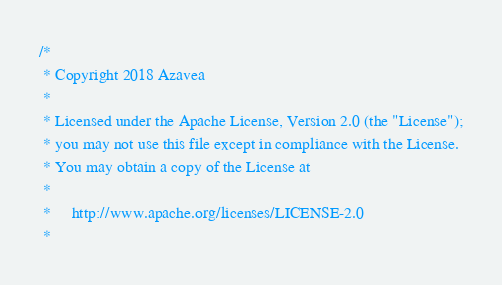Convert code to text. <code><loc_0><loc_0><loc_500><loc_500><_Scala_>/*
 * Copyright 2018 Azavea
 *
 * Licensed under the Apache License, Version 2.0 (the "License");
 * you may not use this file except in compliance with the License.
 * You may obtain a copy of the License at
 *
 *     http://www.apache.org/licenses/LICENSE-2.0
 *</code> 